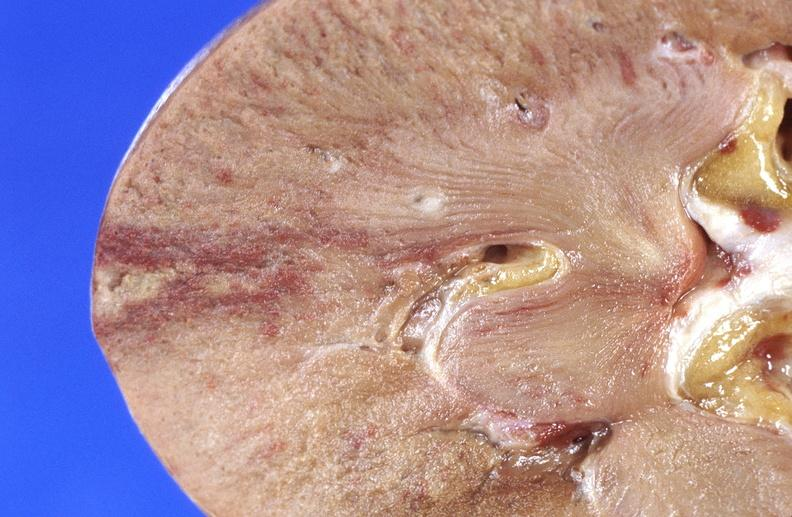does this image show kidney infarct?
Answer the question using a single word or phrase. Yes 